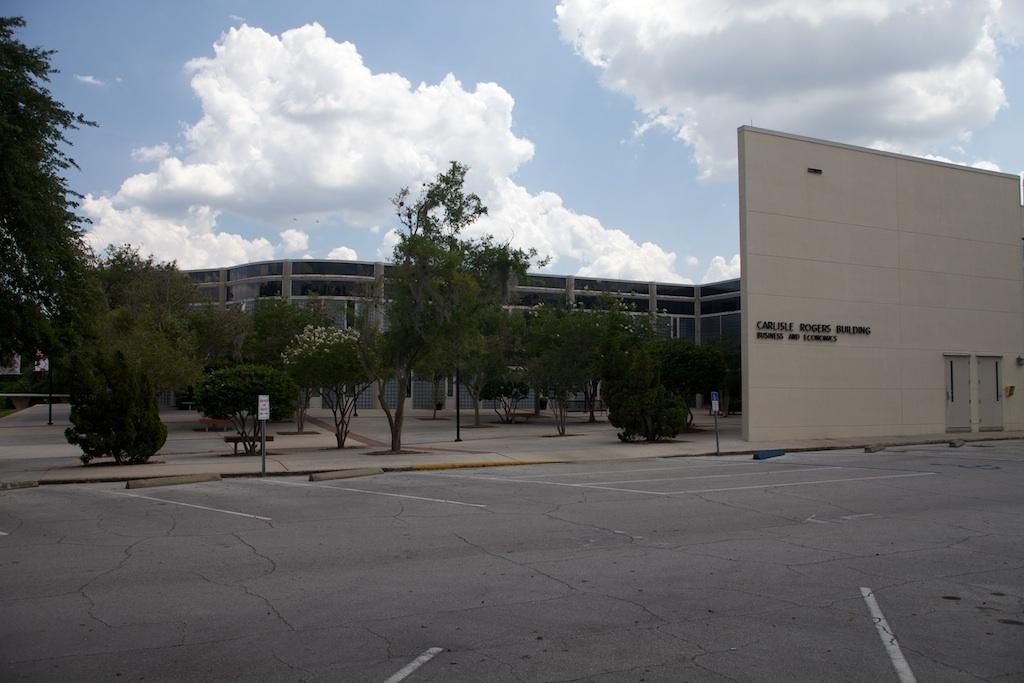Could you give a brief overview of what you see in this image? This image is taken outdoors. At the top of the image there is the sky with clouds. At the bottom of the image there is a road. In the middle of the image there is a building with walls, pillars, windows, doors and a roof. There are a few trees and plants. There is a sign board. On the right side of the image there is a wall with a door and there is a text on the wall. 